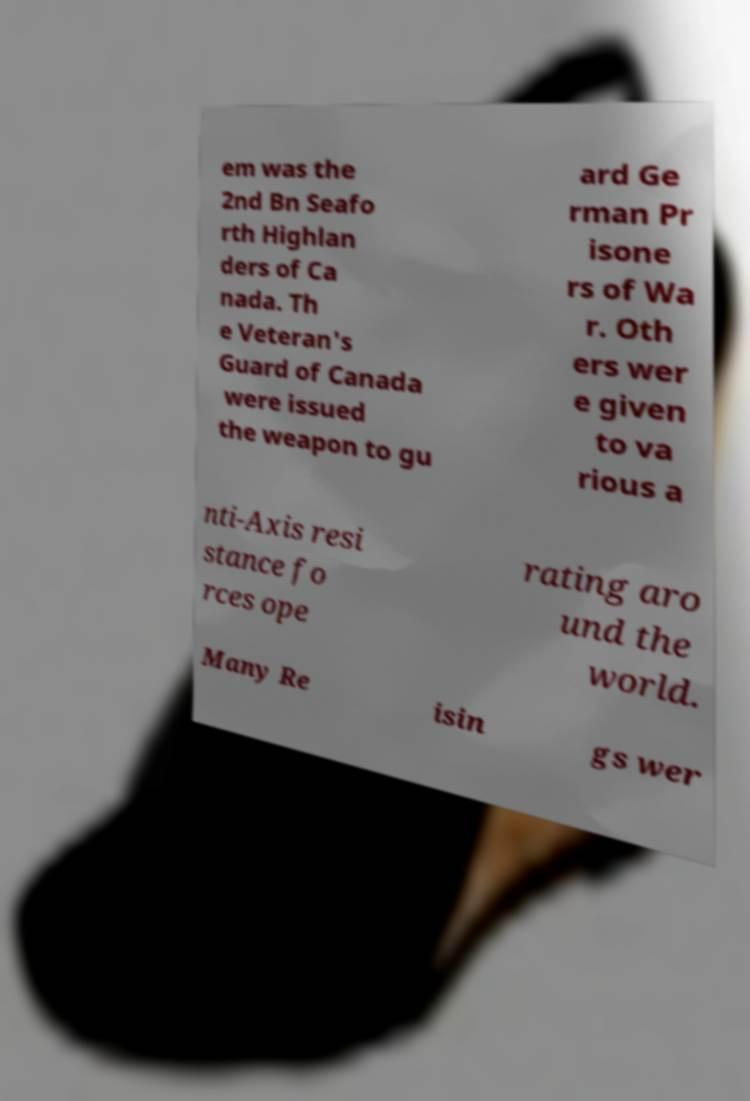Could you assist in decoding the text presented in this image and type it out clearly? em was the 2nd Bn Seafo rth Highlan ders of Ca nada. Th e Veteran's Guard of Canada were issued the weapon to gu ard Ge rman Pr isone rs of Wa r. Oth ers wer e given to va rious a nti-Axis resi stance fo rces ope rating aro und the world. Many Re isin gs wer 